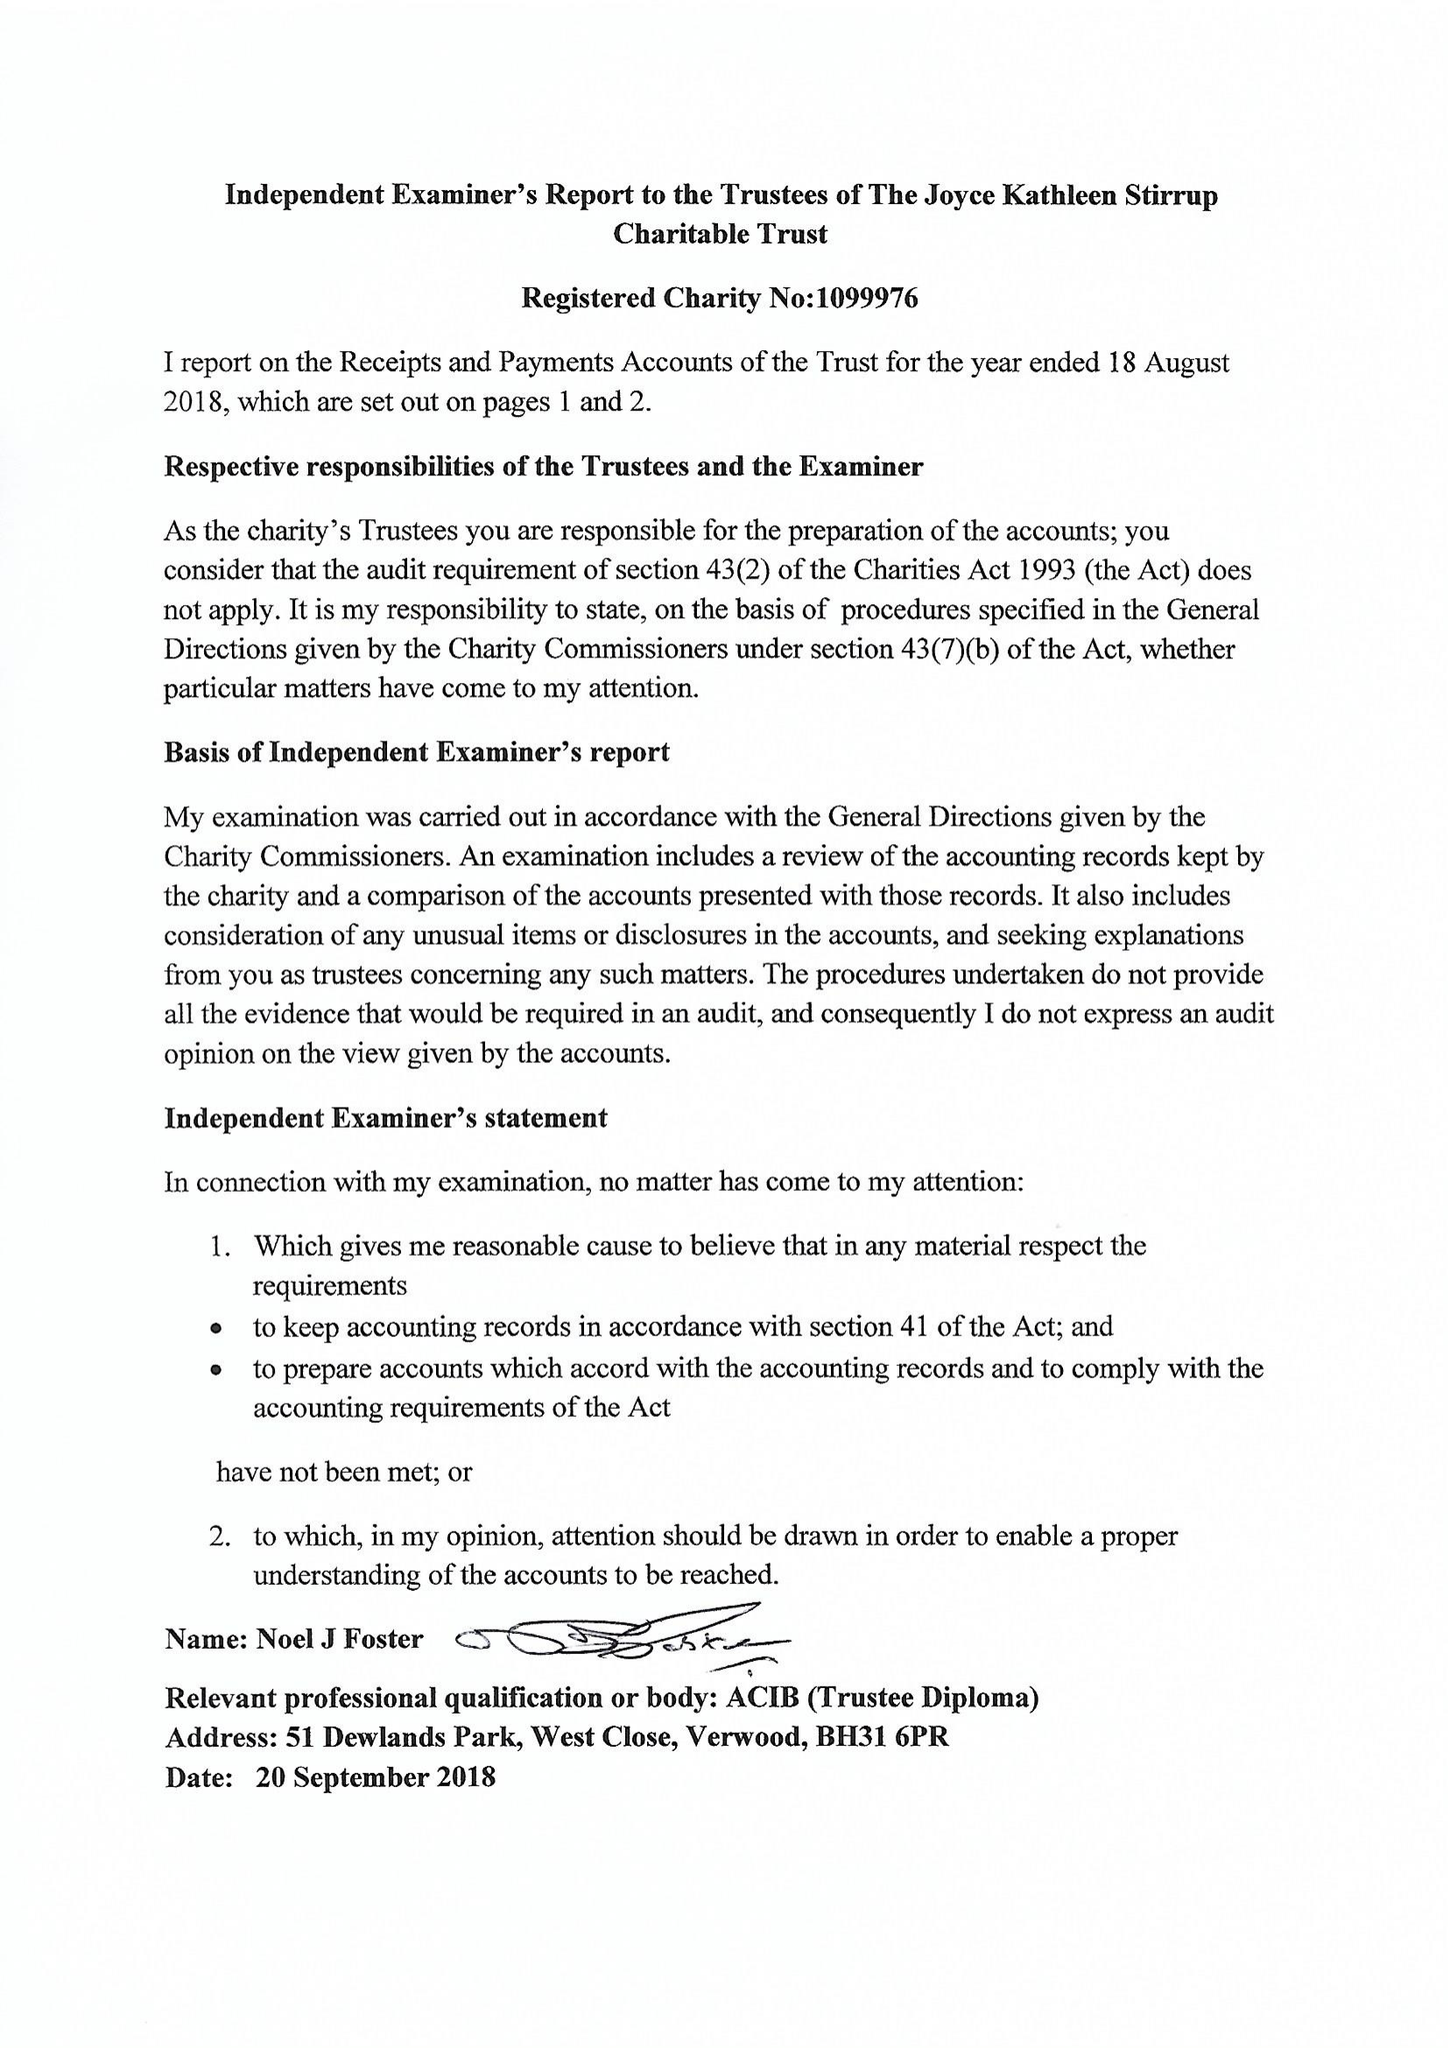What is the value for the address__post_town?
Answer the question using a single word or phrase. BRISTOL 